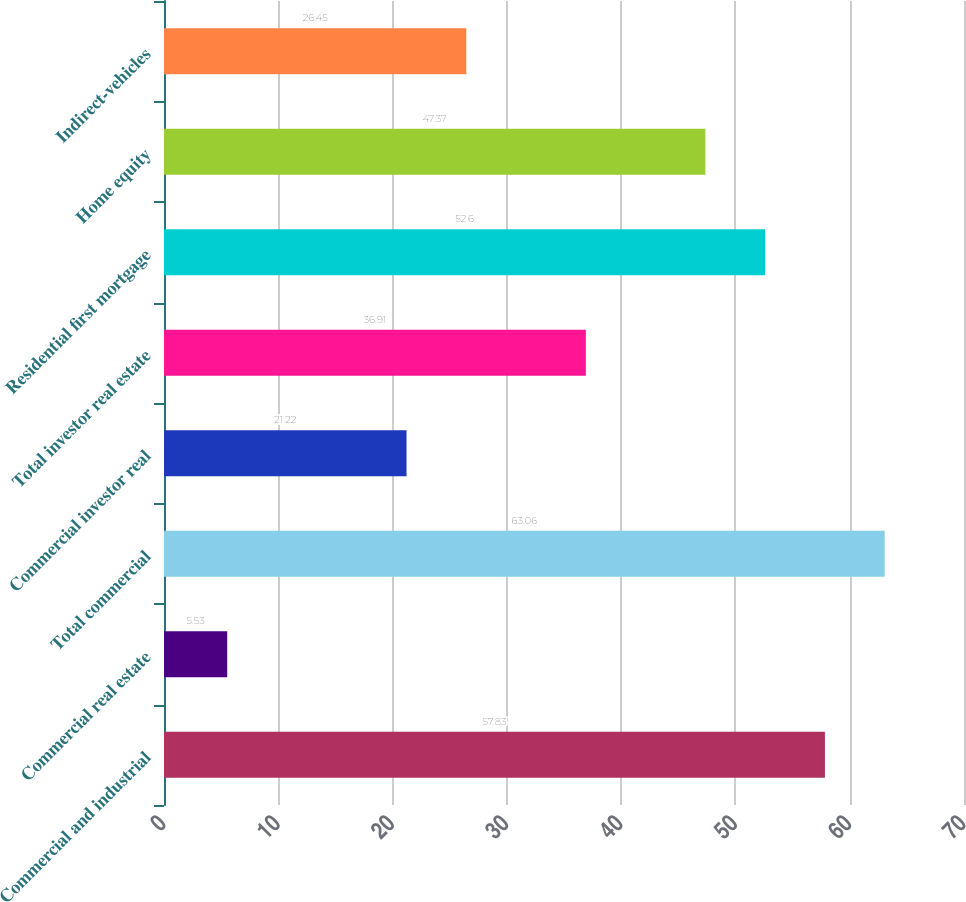Convert chart. <chart><loc_0><loc_0><loc_500><loc_500><bar_chart><fcel>Commercial and industrial<fcel>Commercial real estate<fcel>Total commercial<fcel>Commercial investor real<fcel>Total investor real estate<fcel>Residential first mortgage<fcel>Home equity<fcel>Indirect-vehicles<nl><fcel>57.83<fcel>5.53<fcel>63.06<fcel>21.22<fcel>36.91<fcel>52.6<fcel>47.37<fcel>26.45<nl></chart> 